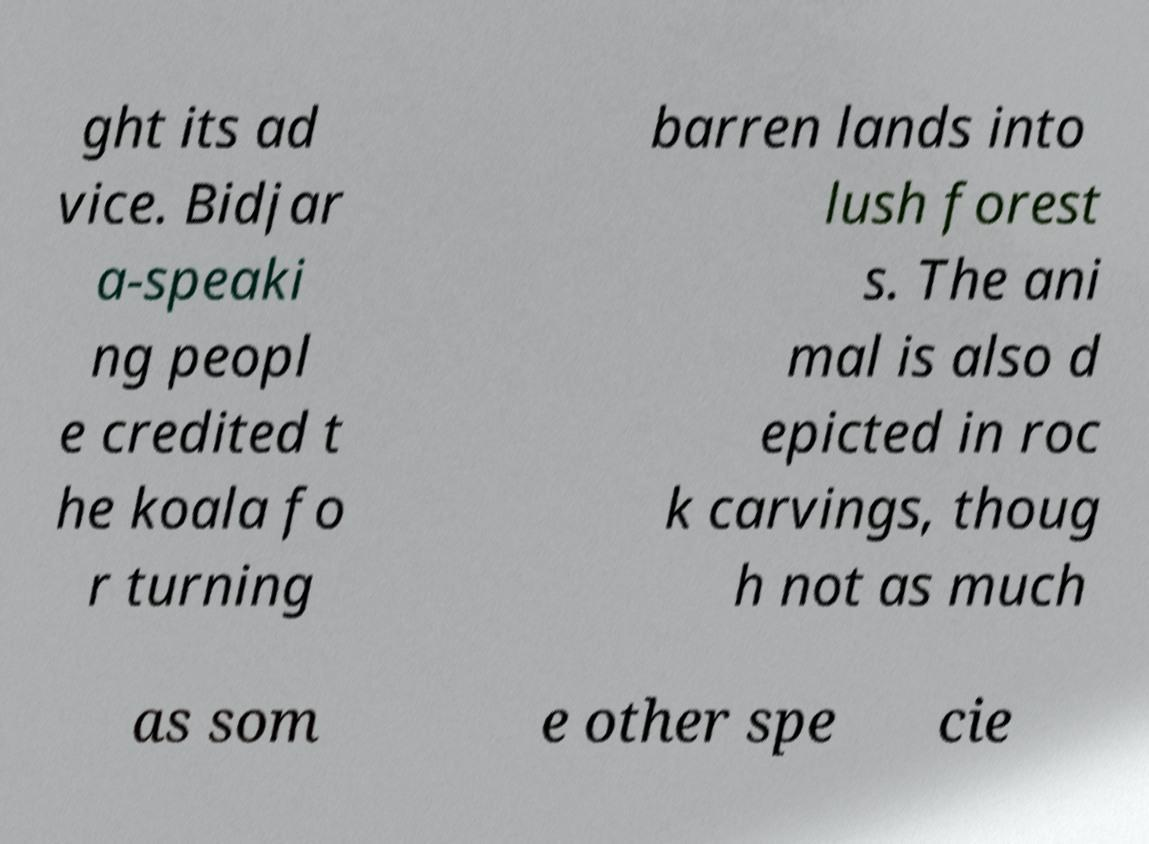Could you extract and type out the text from this image? ght its ad vice. Bidjar a-speaki ng peopl e credited t he koala fo r turning barren lands into lush forest s. The ani mal is also d epicted in roc k carvings, thoug h not as much as som e other spe cie 